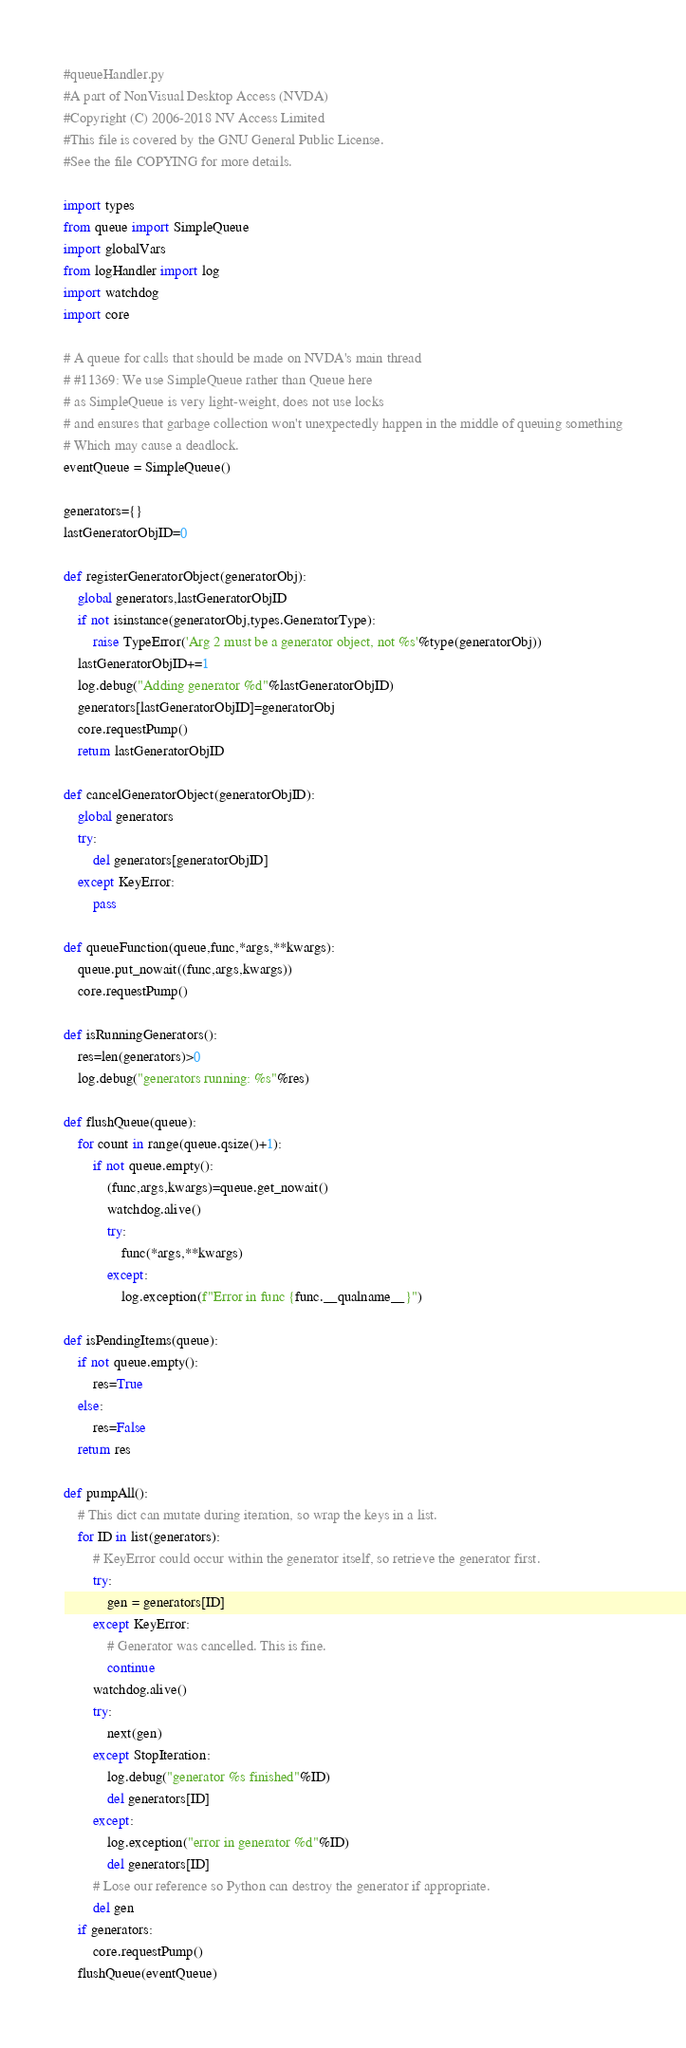Convert code to text. <code><loc_0><loc_0><loc_500><loc_500><_Python_>#queueHandler.py
#A part of NonVisual Desktop Access (NVDA)
#Copyright (C) 2006-2018 NV Access Limited
#This file is covered by the GNU General Public License.
#See the file COPYING for more details.

import types
from queue import SimpleQueue
import globalVars
from logHandler import log
import watchdog
import core

# A queue for calls that should be made on NVDA's main thread
# #11369: We use SimpleQueue rather than Queue here
# as SimpleQueue is very light-weight, does not use locks
# and ensures that garbage collection won't unexpectedly happen in the middle of queuing something
# Which may cause a deadlock.
eventQueue = SimpleQueue()

generators={}
lastGeneratorObjID=0

def registerGeneratorObject(generatorObj):
	global generators,lastGeneratorObjID
	if not isinstance(generatorObj,types.GeneratorType):
		raise TypeError('Arg 2 must be a generator object, not %s'%type(generatorObj))
	lastGeneratorObjID+=1
	log.debug("Adding generator %d"%lastGeneratorObjID)
	generators[lastGeneratorObjID]=generatorObj
	core.requestPump()
	return lastGeneratorObjID

def cancelGeneratorObject(generatorObjID):
	global generators
	try:
		del generators[generatorObjID]
	except KeyError:
		pass

def queueFunction(queue,func,*args,**kwargs):
	queue.put_nowait((func,args,kwargs))
	core.requestPump()

def isRunningGenerators():
	res=len(generators)>0
	log.debug("generators running: %s"%res)

def flushQueue(queue):
	for count in range(queue.qsize()+1):
		if not queue.empty():
			(func,args,kwargs)=queue.get_nowait()
			watchdog.alive()
			try:
				func(*args,**kwargs)
			except:
				log.exception(f"Error in func {func.__qualname__}")

def isPendingItems(queue):
	if not queue.empty():
		res=True
	else:
		res=False
	return res

def pumpAll():
	# This dict can mutate during iteration, so wrap the keys in a list.
	for ID in list(generators):
		# KeyError could occur within the generator itself, so retrieve the generator first.
		try:
			gen = generators[ID]
		except KeyError:
			# Generator was cancelled. This is fine.
			continue
		watchdog.alive()
		try:
			next(gen)
		except StopIteration:
			log.debug("generator %s finished"%ID)
			del generators[ID]
		except:
			log.exception("error in generator %d"%ID)
			del generators[ID]
		# Lose our reference so Python can destroy the generator if appropriate.
		del gen
	if generators:
		core.requestPump()
	flushQueue(eventQueue)
</code> 